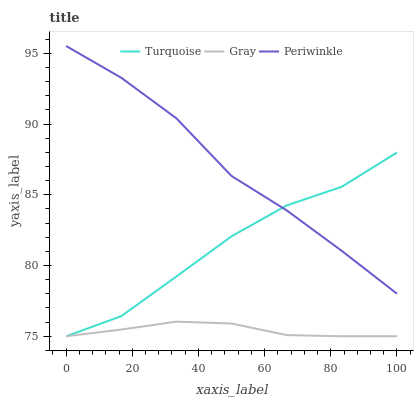Does Gray have the minimum area under the curve?
Answer yes or no. Yes. Does Periwinkle have the maximum area under the curve?
Answer yes or no. Yes. Does Turquoise have the minimum area under the curve?
Answer yes or no. No. Does Turquoise have the maximum area under the curve?
Answer yes or no. No. Is Gray the smoothest?
Answer yes or no. Yes. Is Periwinkle the roughest?
Answer yes or no. Yes. Is Turquoise the smoothest?
Answer yes or no. No. Is Turquoise the roughest?
Answer yes or no. No. Does Gray have the lowest value?
Answer yes or no. Yes. Does Periwinkle have the lowest value?
Answer yes or no. No. Does Periwinkle have the highest value?
Answer yes or no. Yes. Does Turquoise have the highest value?
Answer yes or no. No. Is Gray less than Periwinkle?
Answer yes or no. Yes. Is Periwinkle greater than Gray?
Answer yes or no. Yes. Does Turquoise intersect Gray?
Answer yes or no. Yes. Is Turquoise less than Gray?
Answer yes or no. No. Is Turquoise greater than Gray?
Answer yes or no. No. Does Gray intersect Periwinkle?
Answer yes or no. No. 